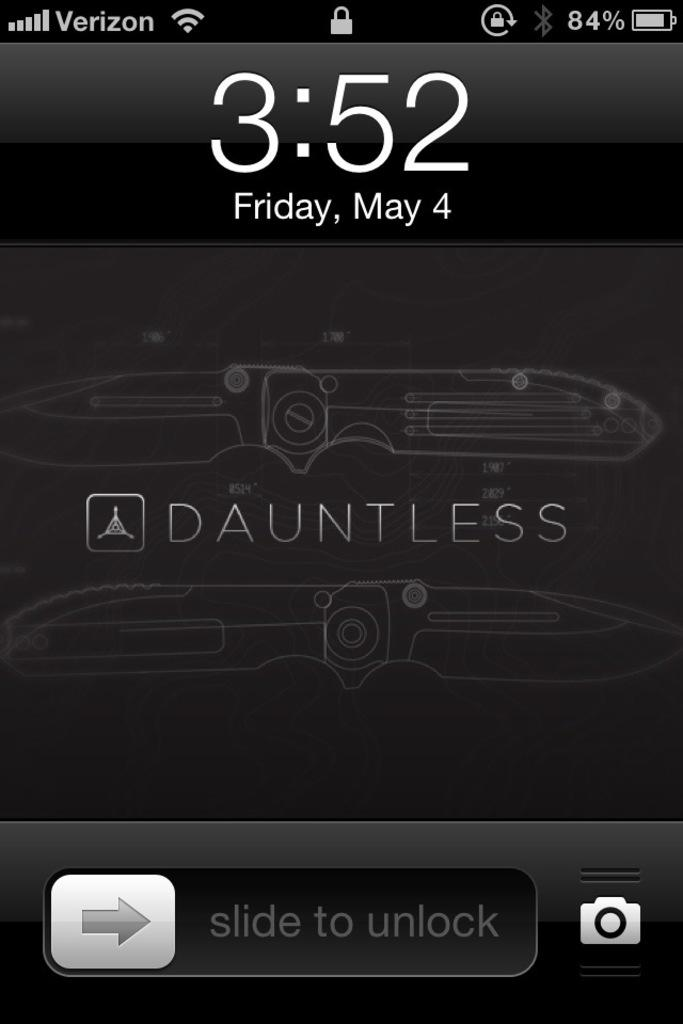<image>
Describe the image concisely. Phone screen which said Dauntless in the middle. 